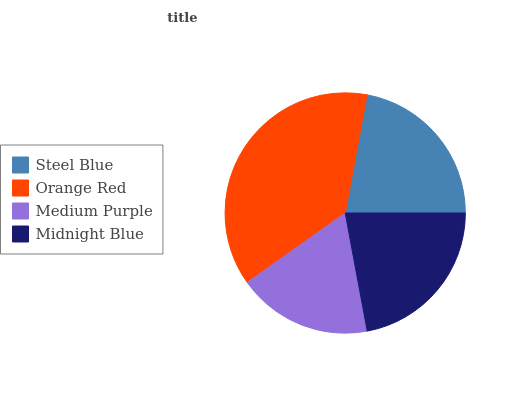Is Medium Purple the minimum?
Answer yes or no. Yes. Is Orange Red the maximum?
Answer yes or no. Yes. Is Orange Red the minimum?
Answer yes or no. No. Is Medium Purple the maximum?
Answer yes or no. No. Is Orange Red greater than Medium Purple?
Answer yes or no. Yes. Is Medium Purple less than Orange Red?
Answer yes or no. Yes. Is Medium Purple greater than Orange Red?
Answer yes or no. No. Is Orange Red less than Medium Purple?
Answer yes or no. No. Is Steel Blue the high median?
Answer yes or no. Yes. Is Midnight Blue the low median?
Answer yes or no. Yes. Is Orange Red the high median?
Answer yes or no. No. Is Steel Blue the low median?
Answer yes or no. No. 